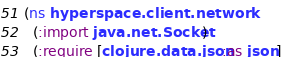Convert code to text. <code><loc_0><loc_0><loc_500><loc_500><_Clojure_>(ns hyperspace.client.network
  (:import java.net.Socket)
  (:require [clojure.data.json :as json]</code> 